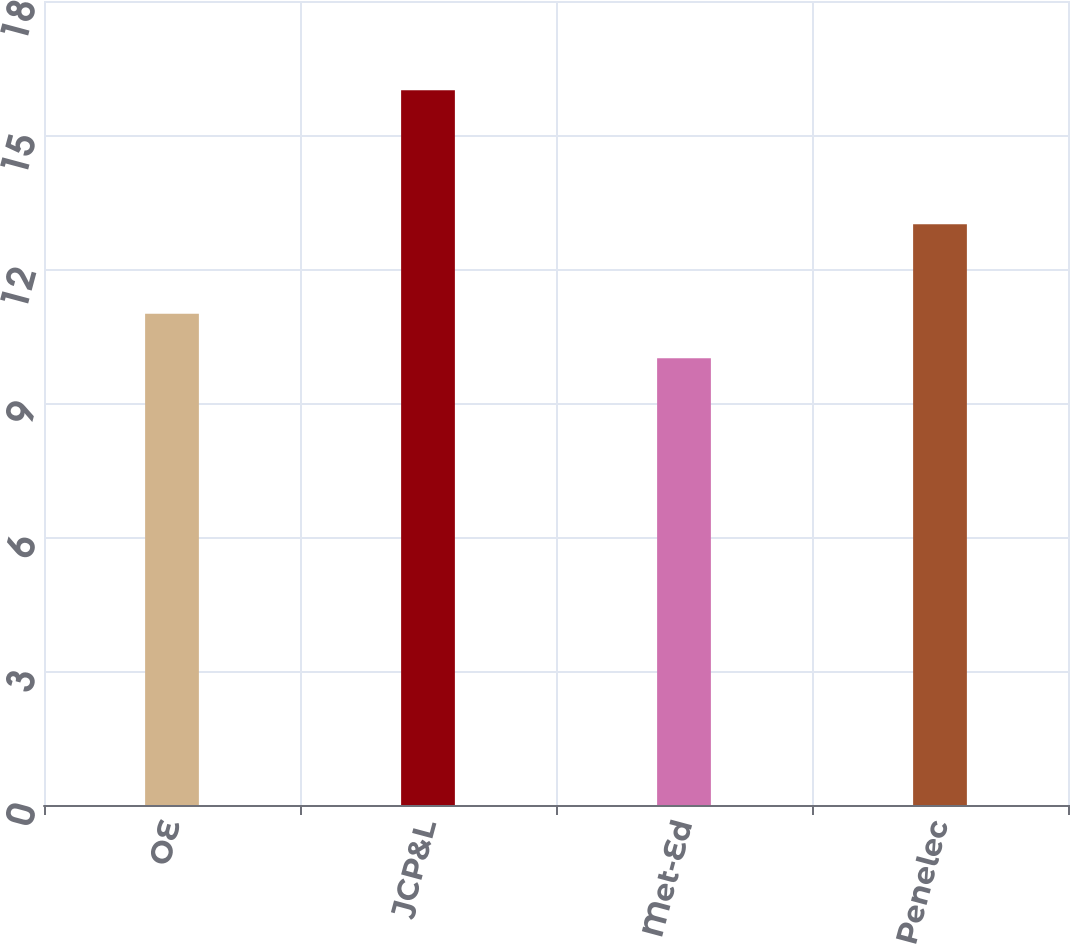Convert chart. <chart><loc_0><loc_0><loc_500><loc_500><bar_chart><fcel>OE<fcel>JCP&L<fcel>Met-Ed<fcel>Penelec<nl><fcel>11<fcel>16<fcel>10<fcel>13<nl></chart> 